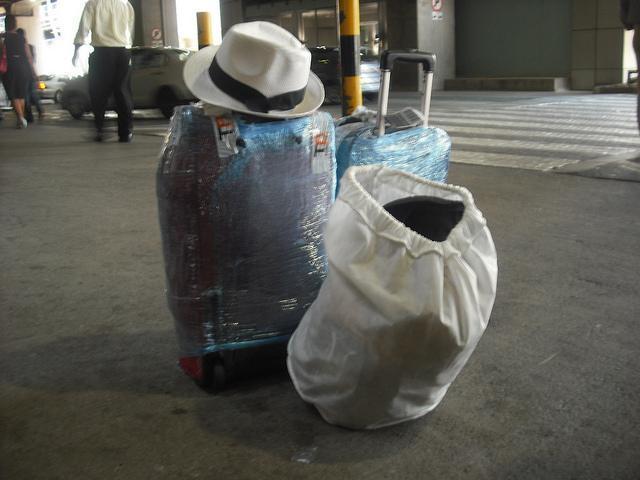How many people can be seen?
Give a very brief answer. 2. How many cars can be seen?
Give a very brief answer. 2. How many suitcases can be seen?
Give a very brief answer. 2. 